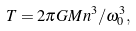<formula> <loc_0><loc_0><loc_500><loc_500>T = 2 \pi G M n ^ { 3 } / \omega _ { 0 } ^ { 3 } ,</formula> 